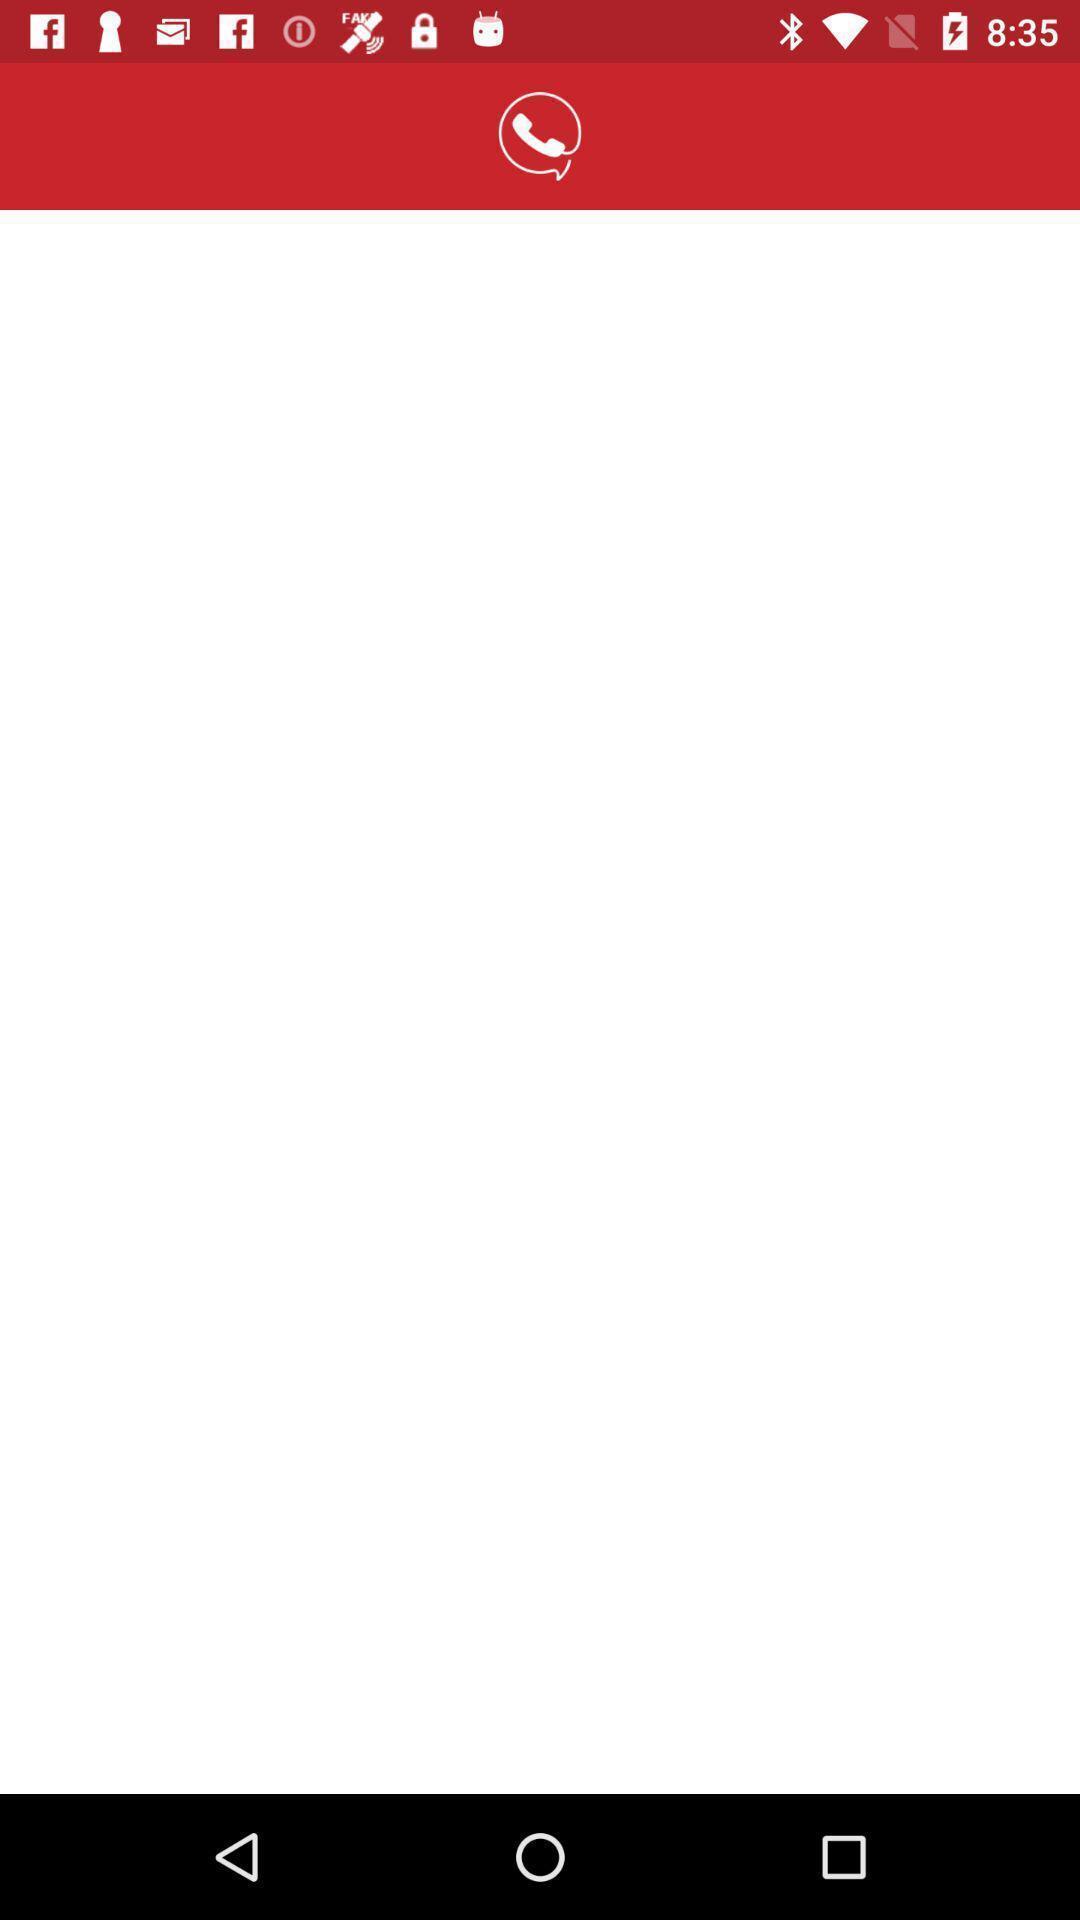Explain what's happening in this screen capture. Screen displaying a blank page with a icon on it. 